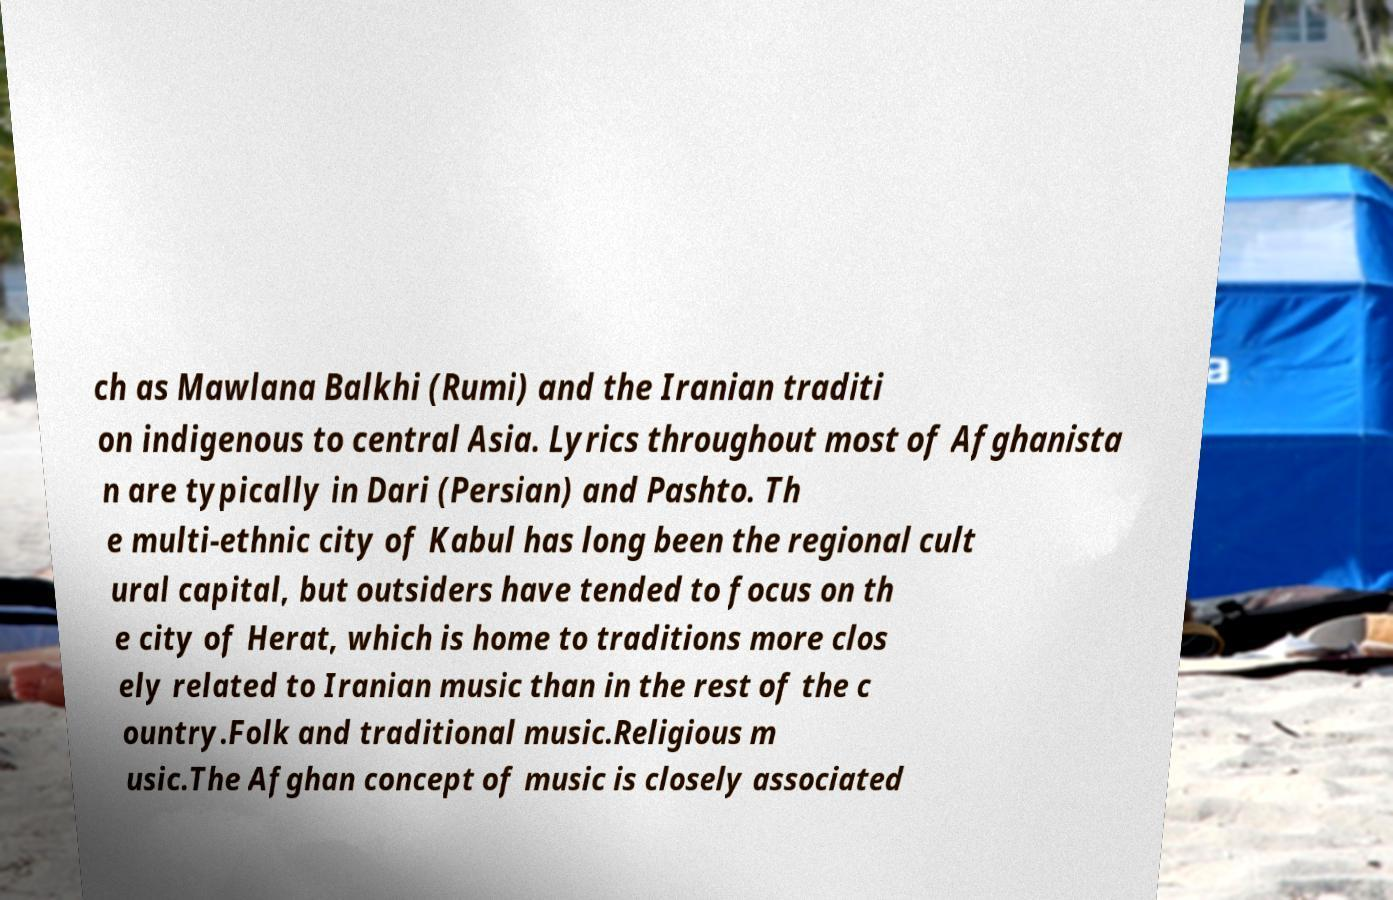I need the written content from this picture converted into text. Can you do that? ch as Mawlana Balkhi (Rumi) and the Iranian traditi on indigenous to central Asia. Lyrics throughout most of Afghanista n are typically in Dari (Persian) and Pashto. Th e multi-ethnic city of Kabul has long been the regional cult ural capital, but outsiders have tended to focus on th e city of Herat, which is home to traditions more clos ely related to Iranian music than in the rest of the c ountry.Folk and traditional music.Religious m usic.The Afghan concept of music is closely associated 